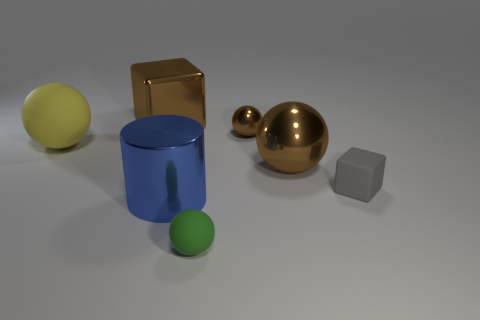Add 2 big purple matte things. How many objects exist? 9 Subtract all spheres. How many objects are left? 3 Add 4 small gray matte cubes. How many small gray matte cubes are left? 5 Add 4 large yellow matte things. How many large yellow matte things exist? 5 Subtract 1 brown cubes. How many objects are left? 6 Subtract all large gray balls. Subtract all green spheres. How many objects are left? 6 